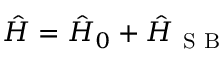<formula> <loc_0><loc_0><loc_500><loc_500>\begin{array} { r } { \hat { H } = \hat { H } _ { 0 } + \hat { H } _ { S B } } \end{array}</formula> 